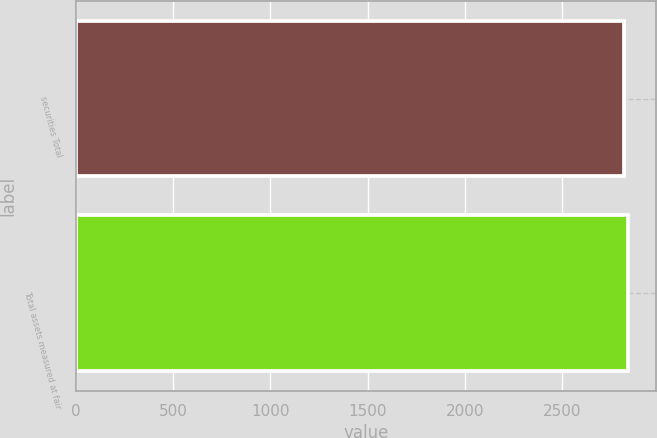Convert chart to OTSL. <chart><loc_0><loc_0><loc_500><loc_500><bar_chart><fcel>securities Total<fcel>Total assets measured at fair<nl><fcel>2816.4<fcel>2838.3<nl></chart> 